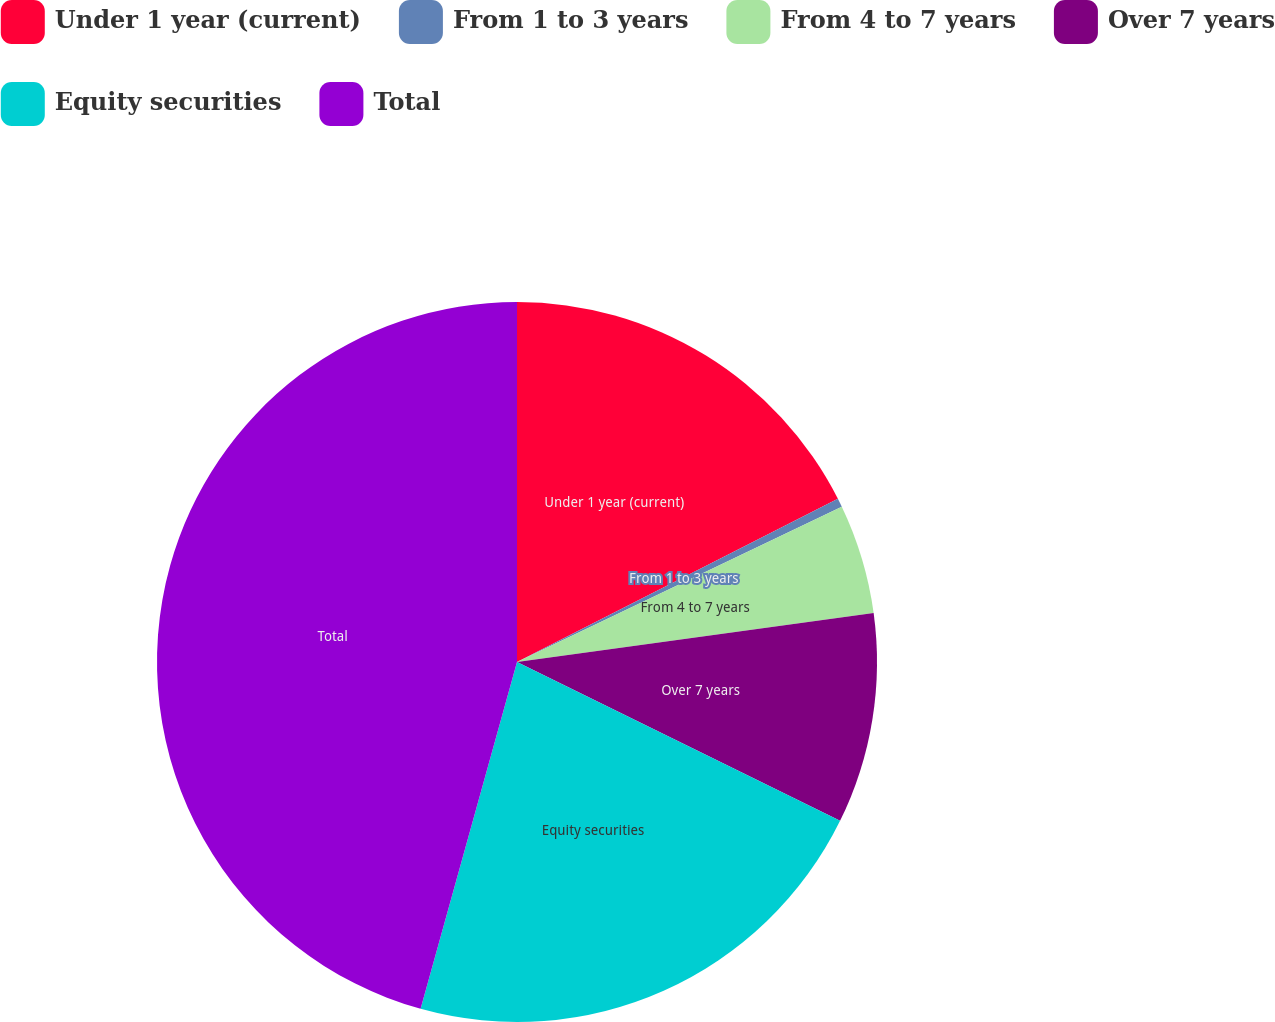Convert chart. <chart><loc_0><loc_0><loc_500><loc_500><pie_chart><fcel>Under 1 year (current)<fcel>From 1 to 3 years<fcel>From 4 to 7 years<fcel>Over 7 years<fcel>Equity securities<fcel>Total<nl><fcel>17.51%<fcel>0.39%<fcel>4.92%<fcel>9.45%<fcel>22.04%<fcel>45.68%<nl></chart> 